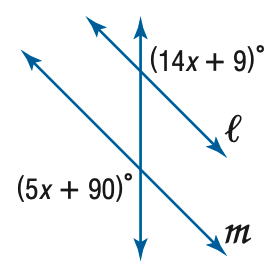Answer the mathemtical geometry problem and directly provide the correct option letter.
Question: Find x so that m \parallel n.
Choices: A: 9 B: 10 C: 11 D: 12 A 